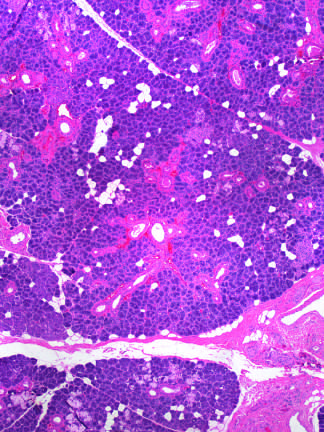re bile duct cells and canals of hering produced by radiation therapy of the neck region?
Answer the question using a single word or phrase. No 